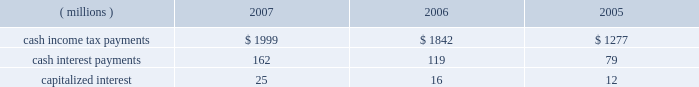In september 2006 , the fasb issued sfas no .
158 , 201cemployers 2019 accounting for defined benefit pension and other postretirement plans , an amendment of fasb statements no .
87 , 88 , 106 and 132 ( r ) . 201d this standard eliminated the requirement for a 201cminimum pension liability adjustment 201d that was previously required under sfas no .
87 and required employers to recognize the underfunded or overfunded status of a defined benefit plan as an asset or liability in its statement of financial position .
In 2006 , as a result of the implementation of sfas no .
158 , the company recognized an after-tax decrease in accumulated other comprehensive income of $ 1.187 billion and $ 513 million for the u.s .
And international pension benefit plans , respectively , and $ 218 million for the postretirement health care and life insurance benefit plan .
See note 11 for additional detail .
Reclassification adjustments are made to avoid double counting in comprehensive income items that are also recorded as part of net income .
In 2007 , as disclosed in the net periodic benefit cost table in note 11 , $ 198 million pre-tax ( $ 123 million after-tax ) were reclassified to earnings from accumulated other comprehensive income to pension and postretirement expense in the income statement .
These pension and postretirement expense amounts are shown in the table in note 11 as amortization of transition ( asset ) obligation , amortization of prior service cost ( benefit ) and amortization of net actuarial ( gain ) loss .
Other reclassification adjustments ( except for cash flow hedging instruments adjustments provided in note 12 ) were not material .
No tax provision has been made for the translation of foreign currency financial statements into u.s .
Dollars .
Note 7 .
Supplemental cash flow information .
Individual amounts in the consolidated statement of cash flows exclude the impacts of acquisitions , divestitures and exchange rate impacts , which are presented separately .
201cother 2013 net 201d in the consolidated statement of cash flows within operating activities in 2007 and 2006 includes changes in liabilities related to 3m 2019s restructuring actions ( note 4 ) and in 2005 includes the non-cash impact of adopting fin 47 ( $ 35 million cumulative effect of accounting change ) .
Transactions related to investing and financing activities with significant non-cash components are as follows : in 2007 , 3m purchased certain assets of diamond productions , inc .
For approximately 150 thousand shares of 3m common stock , which has a market value of approximately $ 13 million at the acquisition 2019s measurement date .
Liabilities assumed from acquisitions are provided in the tables in note 2. .
What was the ratio of the cash income tax payments to the cash interest payments? 
Rationale: in 2007 for every dollar of cash interest payments there was $ 12.34 of spent on cash income tax payments
Computations: (1999 / 162)
Answer: 12.33951. 